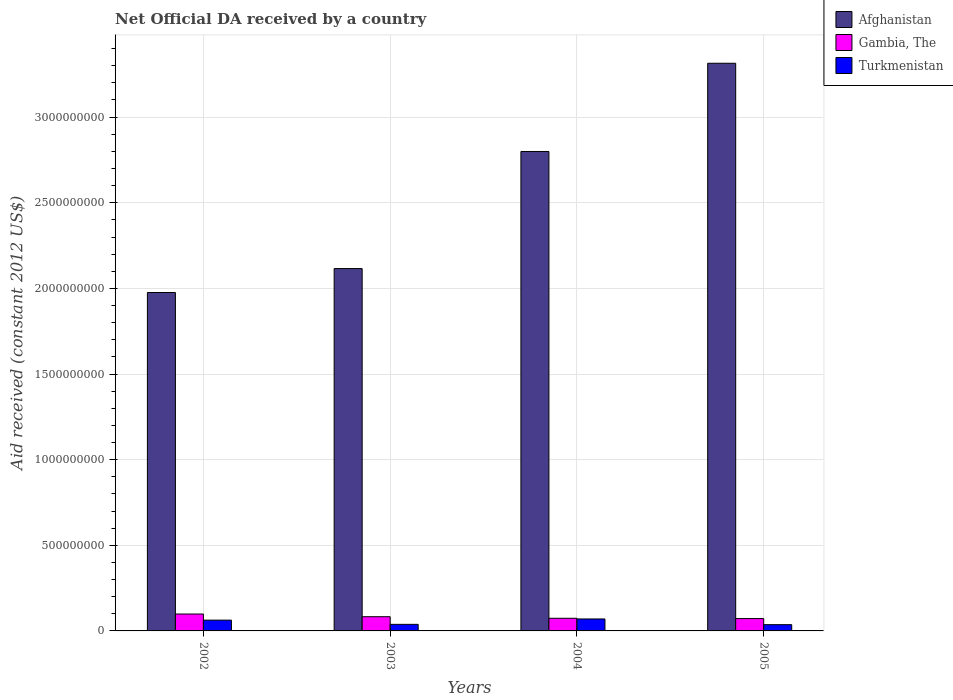How many different coloured bars are there?
Your answer should be compact. 3. How many groups of bars are there?
Keep it short and to the point. 4. Are the number of bars per tick equal to the number of legend labels?
Provide a succinct answer. Yes. Are the number of bars on each tick of the X-axis equal?
Provide a succinct answer. Yes. How many bars are there on the 1st tick from the left?
Make the answer very short. 3. How many bars are there on the 4th tick from the right?
Your answer should be very brief. 3. What is the label of the 3rd group of bars from the left?
Offer a terse response. 2004. In how many cases, is the number of bars for a given year not equal to the number of legend labels?
Your response must be concise. 0. What is the net official development assistance aid received in Afghanistan in 2004?
Your response must be concise. 2.80e+09. Across all years, what is the maximum net official development assistance aid received in Gambia, The?
Make the answer very short. 9.87e+07. Across all years, what is the minimum net official development assistance aid received in Afghanistan?
Provide a succinct answer. 1.98e+09. In which year was the net official development assistance aid received in Turkmenistan maximum?
Your answer should be very brief. 2004. What is the total net official development assistance aid received in Turkmenistan in the graph?
Your response must be concise. 2.08e+08. What is the difference between the net official development assistance aid received in Afghanistan in 2003 and that in 2004?
Your response must be concise. -6.84e+08. What is the difference between the net official development assistance aid received in Afghanistan in 2005 and the net official development assistance aid received in Gambia, The in 2002?
Provide a succinct answer. 3.22e+09. What is the average net official development assistance aid received in Afghanistan per year?
Your answer should be very brief. 2.55e+09. In the year 2005, what is the difference between the net official development assistance aid received in Gambia, The and net official development assistance aid received in Turkmenistan?
Your answer should be very brief. 3.56e+07. What is the ratio of the net official development assistance aid received in Afghanistan in 2002 to that in 2005?
Keep it short and to the point. 0.6. Is the net official development assistance aid received in Turkmenistan in 2002 less than that in 2005?
Your answer should be compact. No. What is the difference between the highest and the second highest net official development assistance aid received in Gambia, The?
Ensure brevity in your answer.  1.57e+07. What is the difference between the highest and the lowest net official development assistance aid received in Turkmenistan?
Your answer should be compact. 3.33e+07. Is the sum of the net official development assistance aid received in Gambia, The in 2002 and 2005 greater than the maximum net official development assistance aid received in Afghanistan across all years?
Offer a very short reply. No. What does the 1st bar from the left in 2005 represents?
Provide a succinct answer. Afghanistan. What does the 1st bar from the right in 2004 represents?
Your response must be concise. Turkmenistan. Is it the case that in every year, the sum of the net official development assistance aid received in Gambia, The and net official development assistance aid received in Afghanistan is greater than the net official development assistance aid received in Turkmenistan?
Your answer should be very brief. Yes. How many bars are there?
Provide a succinct answer. 12. How many years are there in the graph?
Your answer should be compact. 4. What is the difference between two consecutive major ticks on the Y-axis?
Give a very brief answer. 5.00e+08. Does the graph contain any zero values?
Your response must be concise. No. How many legend labels are there?
Offer a terse response. 3. How are the legend labels stacked?
Provide a short and direct response. Vertical. What is the title of the graph?
Offer a very short reply. Net Official DA received by a country. Does "Palau" appear as one of the legend labels in the graph?
Your answer should be compact. No. What is the label or title of the Y-axis?
Offer a terse response. Aid received (constant 2012 US$). What is the Aid received (constant 2012 US$) of Afghanistan in 2002?
Your response must be concise. 1.98e+09. What is the Aid received (constant 2012 US$) in Gambia, The in 2002?
Your response must be concise. 9.87e+07. What is the Aid received (constant 2012 US$) of Turkmenistan in 2002?
Your answer should be very brief. 6.30e+07. What is the Aid received (constant 2012 US$) of Afghanistan in 2003?
Your answer should be very brief. 2.12e+09. What is the Aid received (constant 2012 US$) of Gambia, The in 2003?
Your response must be concise. 8.30e+07. What is the Aid received (constant 2012 US$) in Turkmenistan in 2003?
Provide a succinct answer. 3.83e+07. What is the Aid received (constant 2012 US$) in Afghanistan in 2004?
Ensure brevity in your answer.  2.80e+09. What is the Aid received (constant 2012 US$) in Gambia, The in 2004?
Provide a succinct answer. 7.38e+07. What is the Aid received (constant 2012 US$) in Turkmenistan in 2004?
Keep it short and to the point. 6.99e+07. What is the Aid received (constant 2012 US$) of Afghanistan in 2005?
Provide a succinct answer. 3.31e+09. What is the Aid received (constant 2012 US$) in Gambia, The in 2005?
Offer a terse response. 7.21e+07. What is the Aid received (constant 2012 US$) of Turkmenistan in 2005?
Offer a terse response. 3.65e+07. Across all years, what is the maximum Aid received (constant 2012 US$) in Afghanistan?
Give a very brief answer. 3.31e+09. Across all years, what is the maximum Aid received (constant 2012 US$) in Gambia, The?
Your answer should be very brief. 9.87e+07. Across all years, what is the maximum Aid received (constant 2012 US$) of Turkmenistan?
Your answer should be compact. 6.99e+07. Across all years, what is the minimum Aid received (constant 2012 US$) in Afghanistan?
Offer a terse response. 1.98e+09. Across all years, what is the minimum Aid received (constant 2012 US$) of Gambia, The?
Provide a short and direct response. 7.21e+07. Across all years, what is the minimum Aid received (constant 2012 US$) of Turkmenistan?
Your answer should be very brief. 3.65e+07. What is the total Aid received (constant 2012 US$) of Afghanistan in the graph?
Provide a short and direct response. 1.02e+1. What is the total Aid received (constant 2012 US$) of Gambia, The in the graph?
Make the answer very short. 3.28e+08. What is the total Aid received (constant 2012 US$) in Turkmenistan in the graph?
Provide a succinct answer. 2.08e+08. What is the difference between the Aid received (constant 2012 US$) in Afghanistan in 2002 and that in 2003?
Offer a terse response. -1.40e+08. What is the difference between the Aid received (constant 2012 US$) in Gambia, The in 2002 and that in 2003?
Offer a terse response. 1.57e+07. What is the difference between the Aid received (constant 2012 US$) in Turkmenistan in 2002 and that in 2003?
Offer a very short reply. 2.47e+07. What is the difference between the Aid received (constant 2012 US$) in Afghanistan in 2002 and that in 2004?
Offer a very short reply. -8.23e+08. What is the difference between the Aid received (constant 2012 US$) of Gambia, The in 2002 and that in 2004?
Provide a short and direct response. 2.49e+07. What is the difference between the Aid received (constant 2012 US$) in Turkmenistan in 2002 and that in 2004?
Your answer should be compact. -6.88e+06. What is the difference between the Aid received (constant 2012 US$) in Afghanistan in 2002 and that in 2005?
Your answer should be very brief. -1.34e+09. What is the difference between the Aid received (constant 2012 US$) of Gambia, The in 2002 and that in 2005?
Keep it short and to the point. 2.66e+07. What is the difference between the Aid received (constant 2012 US$) in Turkmenistan in 2002 and that in 2005?
Your answer should be very brief. 2.64e+07. What is the difference between the Aid received (constant 2012 US$) of Afghanistan in 2003 and that in 2004?
Offer a terse response. -6.84e+08. What is the difference between the Aid received (constant 2012 US$) in Gambia, The in 2003 and that in 2004?
Your answer should be compact. 9.16e+06. What is the difference between the Aid received (constant 2012 US$) of Turkmenistan in 2003 and that in 2004?
Make the answer very short. -3.15e+07. What is the difference between the Aid received (constant 2012 US$) in Afghanistan in 2003 and that in 2005?
Make the answer very short. -1.20e+09. What is the difference between the Aid received (constant 2012 US$) of Gambia, The in 2003 and that in 2005?
Provide a short and direct response. 1.09e+07. What is the difference between the Aid received (constant 2012 US$) in Turkmenistan in 2003 and that in 2005?
Offer a terse response. 1.78e+06. What is the difference between the Aid received (constant 2012 US$) of Afghanistan in 2004 and that in 2005?
Provide a succinct answer. -5.15e+08. What is the difference between the Aid received (constant 2012 US$) in Gambia, The in 2004 and that in 2005?
Your response must be concise. 1.71e+06. What is the difference between the Aid received (constant 2012 US$) in Turkmenistan in 2004 and that in 2005?
Give a very brief answer. 3.33e+07. What is the difference between the Aid received (constant 2012 US$) of Afghanistan in 2002 and the Aid received (constant 2012 US$) of Gambia, The in 2003?
Keep it short and to the point. 1.89e+09. What is the difference between the Aid received (constant 2012 US$) in Afghanistan in 2002 and the Aid received (constant 2012 US$) in Turkmenistan in 2003?
Offer a very short reply. 1.94e+09. What is the difference between the Aid received (constant 2012 US$) of Gambia, The in 2002 and the Aid received (constant 2012 US$) of Turkmenistan in 2003?
Your answer should be very brief. 6.04e+07. What is the difference between the Aid received (constant 2012 US$) of Afghanistan in 2002 and the Aid received (constant 2012 US$) of Gambia, The in 2004?
Your answer should be compact. 1.90e+09. What is the difference between the Aid received (constant 2012 US$) of Afghanistan in 2002 and the Aid received (constant 2012 US$) of Turkmenistan in 2004?
Keep it short and to the point. 1.91e+09. What is the difference between the Aid received (constant 2012 US$) of Gambia, The in 2002 and the Aid received (constant 2012 US$) of Turkmenistan in 2004?
Keep it short and to the point. 2.89e+07. What is the difference between the Aid received (constant 2012 US$) in Afghanistan in 2002 and the Aid received (constant 2012 US$) in Gambia, The in 2005?
Provide a short and direct response. 1.90e+09. What is the difference between the Aid received (constant 2012 US$) of Afghanistan in 2002 and the Aid received (constant 2012 US$) of Turkmenistan in 2005?
Offer a terse response. 1.94e+09. What is the difference between the Aid received (constant 2012 US$) of Gambia, The in 2002 and the Aid received (constant 2012 US$) of Turkmenistan in 2005?
Your response must be concise. 6.22e+07. What is the difference between the Aid received (constant 2012 US$) of Afghanistan in 2003 and the Aid received (constant 2012 US$) of Gambia, The in 2004?
Your response must be concise. 2.04e+09. What is the difference between the Aid received (constant 2012 US$) in Afghanistan in 2003 and the Aid received (constant 2012 US$) in Turkmenistan in 2004?
Your answer should be compact. 2.05e+09. What is the difference between the Aid received (constant 2012 US$) in Gambia, The in 2003 and the Aid received (constant 2012 US$) in Turkmenistan in 2004?
Provide a short and direct response. 1.31e+07. What is the difference between the Aid received (constant 2012 US$) of Afghanistan in 2003 and the Aid received (constant 2012 US$) of Gambia, The in 2005?
Provide a short and direct response. 2.04e+09. What is the difference between the Aid received (constant 2012 US$) in Afghanistan in 2003 and the Aid received (constant 2012 US$) in Turkmenistan in 2005?
Offer a very short reply. 2.08e+09. What is the difference between the Aid received (constant 2012 US$) of Gambia, The in 2003 and the Aid received (constant 2012 US$) of Turkmenistan in 2005?
Provide a succinct answer. 4.65e+07. What is the difference between the Aid received (constant 2012 US$) in Afghanistan in 2004 and the Aid received (constant 2012 US$) in Gambia, The in 2005?
Give a very brief answer. 2.73e+09. What is the difference between the Aid received (constant 2012 US$) of Afghanistan in 2004 and the Aid received (constant 2012 US$) of Turkmenistan in 2005?
Provide a short and direct response. 2.76e+09. What is the difference between the Aid received (constant 2012 US$) of Gambia, The in 2004 and the Aid received (constant 2012 US$) of Turkmenistan in 2005?
Offer a terse response. 3.73e+07. What is the average Aid received (constant 2012 US$) of Afghanistan per year?
Offer a terse response. 2.55e+09. What is the average Aid received (constant 2012 US$) in Gambia, The per year?
Provide a succinct answer. 8.19e+07. What is the average Aid received (constant 2012 US$) of Turkmenistan per year?
Offer a terse response. 5.19e+07. In the year 2002, what is the difference between the Aid received (constant 2012 US$) in Afghanistan and Aid received (constant 2012 US$) in Gambia, The?
Offer a very short reply. 1.88e+09. In the year 2002, what is the difference between the Aid received (constant 2012 US$) in Afghanistan and Aid received (constant 2012 US$) in Turkmenistan?
Give a very brief answer. 1.91e+09. In the year 2002, what is the difference between the Aid received (constant 2012 US$) of Gambia, The and Aid received (constant 2012 US$) of Turkmenistan?
Your response must be concise. 3.58e+07. In the year 2003, what is the difference between the Aid received (constant 2012 US$) in Afghanistan and Aid received (constant 2012 US$) in Gambia, The?
Your answer should be very brief. 2.03e+09. In the year 2003, what is the difference between the Aid received (constant 2012 US$) of Afghanistan and Aid received (constant 2012 US$) of Turkmenistan?
Your response must be concise. 2.08e+09. In the year 2003, what is the difference between the Aid received (constant 2012 US$) in Gambia, The and Aid received (constant 2012 US$) in Turkmenistan?
Offer a very short reply. 4.47e+07. In the year 2004, what is the difference between the Aid received (constant 2012 US$) of Afghanistan and Aid received (constant 2012 US$) of Gambia, The?
Your answer should be very brief. 2.73e+09. In the year 2004, what is the difference between the Aid received (constant 2012 US$) of Afghanistan and Aid received (constant 2012 US$) of Turkmenistan?
Your answer should be very brief. 2.73e+09. In the year 2004, what is the difference between the Aid received (constant 2012 US$) of Gambia, The and Aid received (constant 2012 US$) of Turkmenistan?
Your answer should be very brief. 3.98e+06. In the year 2005, what is the difference between the Aid received (constant 2012 US$) of Afghanistan and Aid received (constant 2012 US$) of Gambia, The?
Ensure brevity in your answer.  3.24e+09. In the year 2005, what is the difference between the Aid received (constant 2012 US$) in Afghanistan and Aid received (constant 2012 US$) in Turkmenistan?
Offer a terse response. 3.28e+09. In the year 2005, what is the difference between the Aid received (constant 2012 US$) of Gambia, The and Aid received (constant 2012 US$) of Turkmenistan?
Give a very brief answer. 3.56e+07. What is the ratio of the Aid received (constant 2012 US$) in Afghanistan in 2002 to that in 2003?
Provide a short and direct response. 0.93. What is the ratio of the Aid received (constant 2012 US$) in Gambia, The in 2002 to that in 2003?
Ensure brevity in your answer.  1.19. What is the ratio of the Aid received (constant 2012 US$) of Turkmenistan in 2002 to that in 2003?
Offer a very short reply. 1.64. What is the ratio of the Aid received (constant 2012 US$) in Afghanistan in 2002 to that in 2004?
Keep it short and to the point. 0.71. What is the ratio of the Aid received (constant 2012 US$) of Gambia, The in 2002 to that in 2004?
Provide a short and direct response. 1.34. What is the ratio of the Aid received (constant 2012 US$) in Turkmenistan in 2002 to that in 2004?
Your response must be concise. 0.9. What is the ratio of the Aid received (constant 2012 US$) of Afghanistan in 2002 to that in 2005?
Give a very brief answer. 0.6. What is the ratio of the Aid received (constant 2012 US$) in Gambia, The in 2002 to that in 2005?
Ensure brevity in your answer.  1.37. What is the ratio of the Aid received (constant 2012 US$) of Turkmenistan in 2002 to that in 2005?
Your answer should be compact. 1.72. What is the ratio of the Aid received (constant 2012 US$) of Afghanistan in 2003 to that in 2004?
Give a very brief answer. 0.76. What is the ratio of the Aid received (constant 2012 US$) of Gambia, The in 2003 to that in 2004?
Ensure brevity in your answer.  1.12. What is the ratio of the Aid received (constant 2012 US$) of Turkmenistan in 2003 to that in 2004?
Provide a short and direct response. 0.55. What is the ratio of the Aid received (constant 2012 US$) of Afghanistan in 2003 to that in 2005?
Give a very brief answer. 0.64. What is the ratio of the Aid received (constant 2012 US$) in Gambia, The in 2003 to that in 2005?
Give a very brief answer. 1.15. What is the ratio of the Aid received (constant 2012 US$) of Turkmenistan in 2003 to that in 2005?
Keep it short and to the point. 1.05. What is the ratio of the Aid received (constant 2012 US$) of Afghanistan in 2004 to that in 2005?
Your response must be concise. 0.84. What is the ratio of the Aid received (constant 2012 US$) of Gambia, The in 2004 to that in 2005?
Make the answer very short. 1.02. What is the ratio of the Aid received (constant 2012 US$) in Turkmenistan in 2004 to that in 2005?
Your answer should be very brief. 1.91. What is the difference between the highest and the second highest Aid received (constant 2012 US$) of Afghanistan?
Your answer should be compact. 5.15e+08. What is the difference between the highest and the second highest Aid received (constant 2012 US$) of Gambia, The?
Offer a terse response. 1.57e+07. What is the difference between the highest and the second highest Aid received (constant 2012 US$) in Turkmenistan?
Keep it short and to the point. 6.88e+06. What is the difference between the highest and the lowest Aid received (constant 2012 US$) in Afghanistan?
Make the answer very short. 1.34e+09. What is the difference between the highest and the lowest Aid received (constant 2012 US$) in Gambia, The?
Your answer should be compact. 2.66e+07. What is the difference between the highest and the lowest Aid received (constant 2012 US$) of Turkmenistan?
Provide a short and direct response. 3.33e+07. 